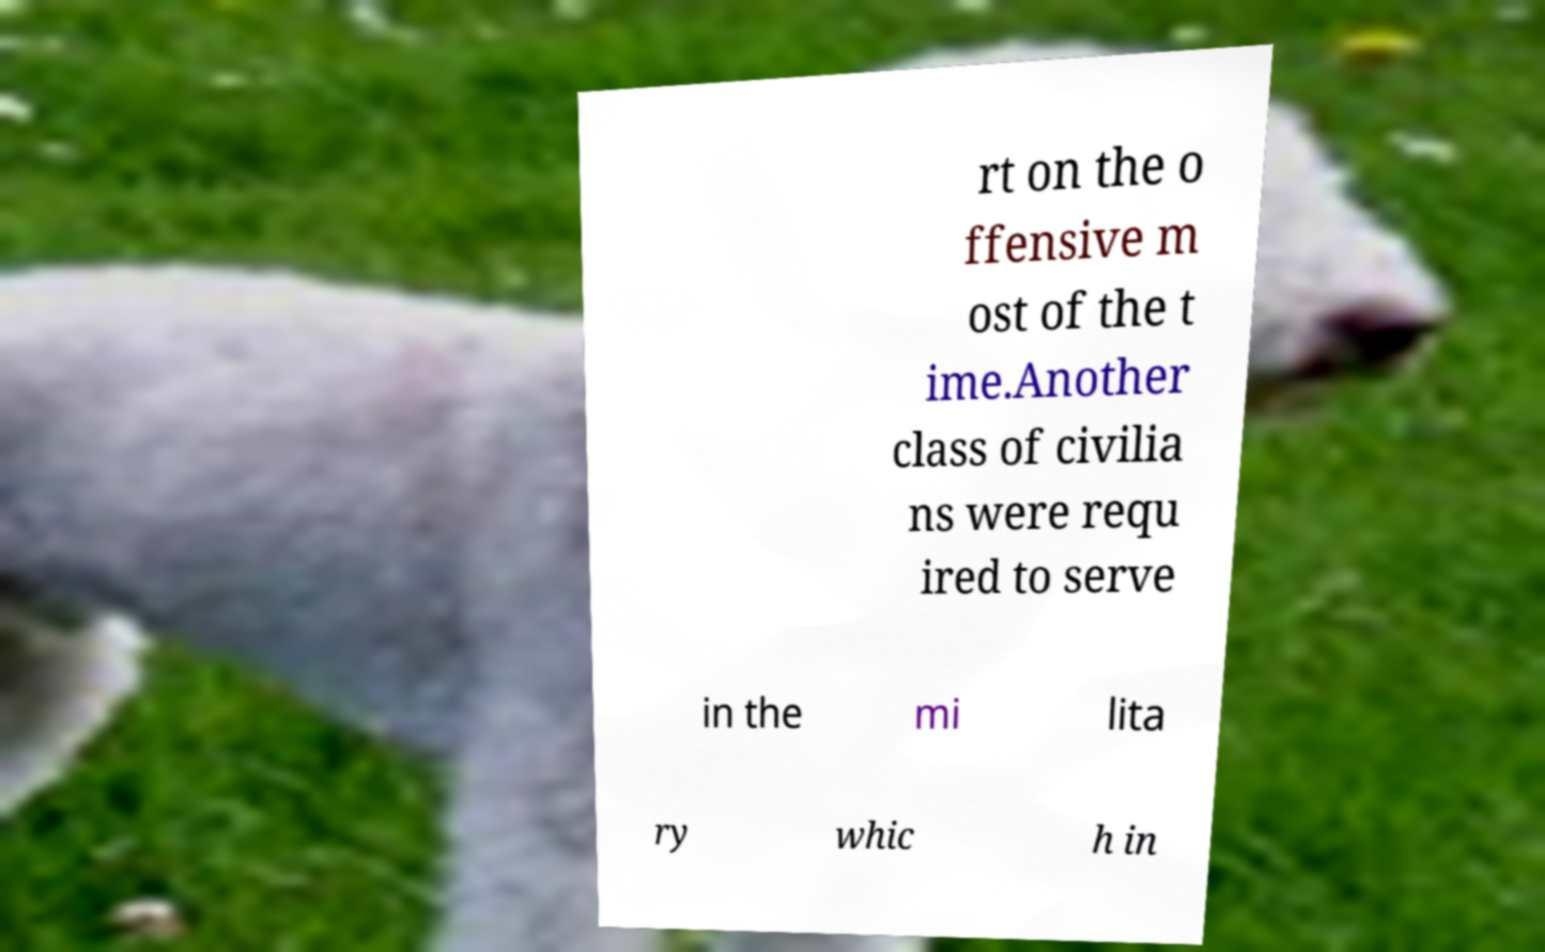Could you assist in decoding the text presented in this image and type it out clearly? rt on the o ffensive m ost of the t ime.Another class of civilia ns were requ ired to serve in the mi lita ry whic h in 